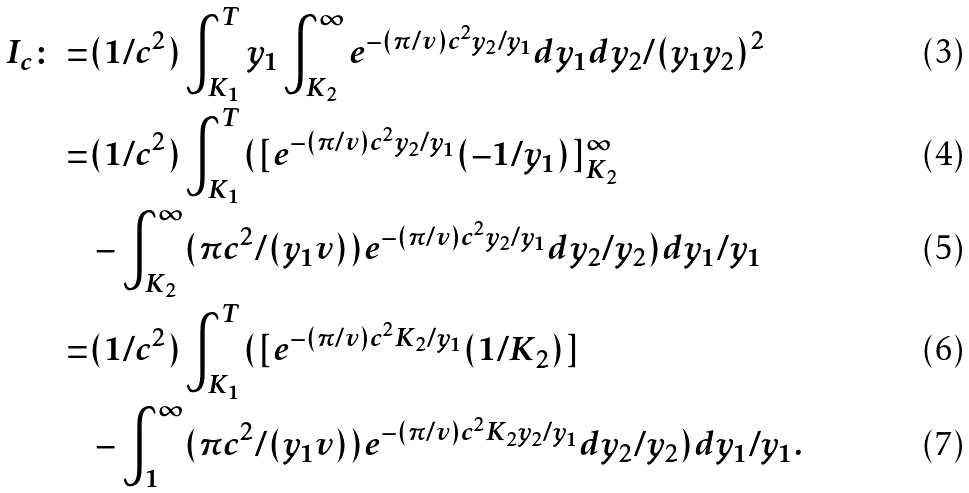<formula> <loc_0><loc_0><loc_500><loc_500>I _ { c } \colon = & ( 1 / c ^ { 2 } ) \int _ { K _ { 1 } } ^ { T } y _ { 1 } \int _ { K _ { 2 } } ^ { \infty } e ^ { - ( \pi / v ) c ^ { 2 } y _ { 2 } / y _ { 1 } } d y _ { 1 } d y _ { 2 } / ( y _ { 1 } y _ { 2 } ) ^ { 2 } \\ = & ( 1 / c ^ { 2 } ) \int _ { K _ { 1 } } ^ { T } ( [ e ^ { - ( \pi / v ) c ^ { 2 } y _ { 2 } / y _ { 1 } } ( - 1 / y _ { 1 } ) ] _ { K _ { 2 } } ^ { \infty } \\ & - \int _ { K _ { 2 } } ^ { \infty } ( \pi c ^ { 2 } / ( y _ { 1 } v ) ) e ^ { - ( \pi / v ) c ^ { 2 } y _ { 2 } / y _ { 1 } } d y _ { 2 } / y _ { 2 } ) d y _ { 1 } / y _ { 1 } \\ = & ( 1 / c ^ { 2 } ) \int _ { K _ { 1 } } ^ { T } ( [ e ^ { - ( \pi / v ) c ^ { 2 } K _ { 2 } / y _ { 1 } } ( 1 / K _ { 2 } ) ] \\ & - \int _ { 1 } ^ { \infty } ( \pi c ^ { 2 } / ( y _ { 1 } v ) ) e ^ { - ( \pi / v ) c ^ { 2 } K _ { 2 } y _ { 2 } / y _ { 1 } } d y _ { 2 } / y _ { 2 } ) d y _ { 1 } / y _ { 1 } .</formula> 